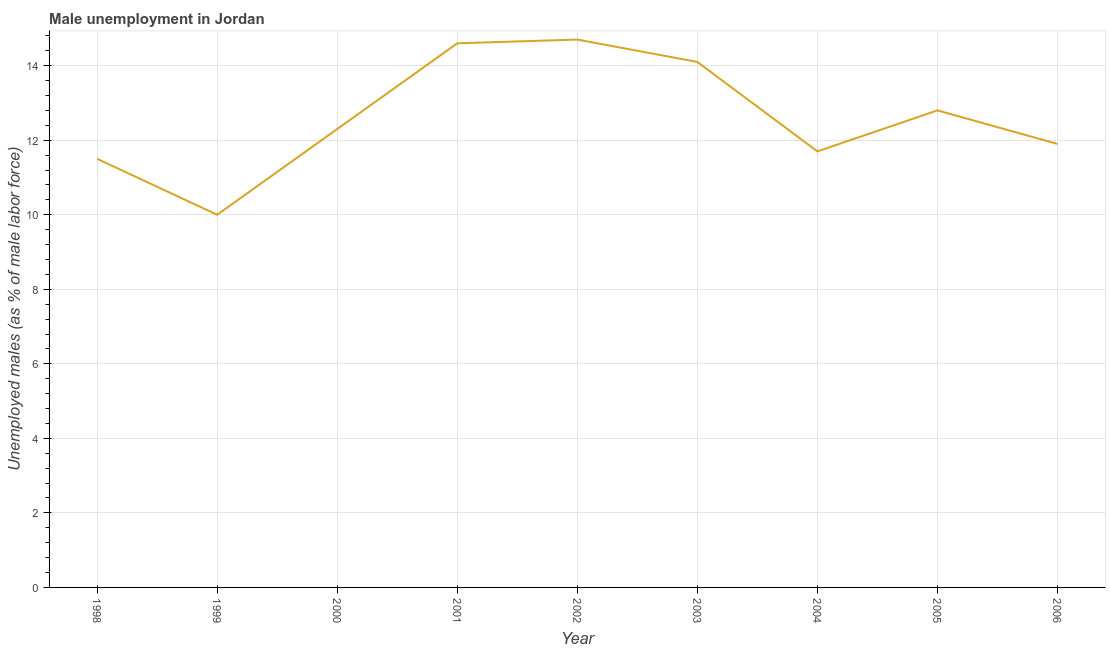What is the unemployed males population in 2004?
Keep it short and to the point. 11.7. Across all years, what is the maximum unemployed males population?
Your answer should be compact. 14.7. In which year was the unemployed males population maximum?
Ensure brevity in your answer.  2002. What is the sum of the unemployed males population?
Your answer should be compact. 113.6. What is the difference between the unemployed males population in 2000 and 2006?
Offer a very short reply. 0.4. What is the average unemployed males population per year?
Ensure brevity in your answer.  12.62. What is the median unemployed males population?
Your response must be concise. 12.3. In how many years, is the unemployed males population greater than 2 %?
Your answer should be compact. 9. What is the ratio of the unemployed males population in 2004 to that in 2006?
Your answer should be compact. 0.98. What is the difference between the highest and the second highest unemployed males population?
Offer a terse response. 0.1. What is the difference between the highest and the lowest unemployed males population?
Ensure brevity in your answer.  4.7. Does the unemployed males population monotonically increase over the years?
Your answer should be very brief. No. How many years are there in the graph?
Provide a short and direct response. 9. Are the values on the major ticks of Y-axis written in scientific E-notation?
Provide a short and direct response. No. Does the graph contain grids?
Keep it short and to the point. Yes. What is the title of the graph?
Provide a succinct answer. Male unemployment in Jordan. What is the label or title of the X-axis?
Your answer should be very brief. Year. What is the label or title of the Y-axis?
Offer a very short reply. Unemployed males (as % of male labor force). What is the Unemployed males (as % of male labor force) of 1999?
Offer a very short reply. 10. What is the Unemployed males (as % of male labor force) in 2000?
Make the answer very short. 12.3. What is the Unemployed males (as % of male labor force) of 2001?
Make the answer very short. 14.6. What is the Unemployed males (as % of male labor force) of 2002?
Ensure brevity in your answer.  14.7. What is the Unemployed males (as % of male labor force) of 2003?
Your answer should be compact. 14.1. What is the Unemployed males (as % of male labor force) in 2004?
Offer a very short reply. 11.7. What is the Unemployed males (as % of male labor force) in 2005?
Offer a very short reply. 12.8. What is the Unemployed males (as % of male labor force) of 2006?
Offer a terse response. 11.9. What is the difference between the Unemployed males (as % of male labor force) in 1998 and 1999?
Ensure brevity in your answer.  1.5. What is the difference between the Unemployed males (as % of male labor force) in 1998 and 2001?
Your response must be concise. -3.1. What is the difference between the Unemployed males (as % of male labor force) in 1998 and 2002?
Your answer should be compact. -3.2. What is the difference between the Unemployed males (as % of male labor force) in 1998 and 2003?
Ensure brevity in your answer.  -2.6. What is the difference between the Unemployed males (as % of male labor force) in 1998 and 2004?
Provide a short and direct response. -0.2. What is the difference between the Unemployed males (as % of male labor force) in 1998 and 2006?
Provide a short and direct response. -0.4. What is the difference between the Unemployed males (as % of male labor force) in 1999 and 2000?
Make the answer very short. -2.3. What is the difference between the Unemployed males (as % of male labor force) in 1999 and 2002?
Give a very brief answer. -4.7. What is the difference between the Unemployed males (as % of male labor force) in 1999 and 2004?
Offer a very short reply. -1.7. What is the difference between the Unemployed males (as % of male labor force) in 2000 and 2003?
Ensure brevity in your answer.  -1.8. What is the difference between the Unemployed males (as % of male labor force) in 2001 and 2005?
Your answer should be very brief. 1.8. What is the difference between the Unemployed males (as % of male labor force) in 2003 and 2006?
Offer a very short reply. 2.2. What is the difference between the Unemployed males (as % of male labor force) in 2004 and 2006?
Make the answer very short. -0.2. What is the difference between the Unemployed males (as % of male labor force) in 2005 and 2006?
Provide a succinct answer. 0.9. What is the ratio of the Unemployed males (as % of male labor force) in 1998 to that in 1999?
Make the answer very short. 1.15. What is the ratio of the Unemployed males (as % of male labor force) in 1998 to that in 2000?
Make the answer very short. 0.94. What is the ratio of the Unemployed males (as % of male labor force) in 1998 to that in 2001?
Offer a very short reply. 0.79. What is the ratio of the Unemployed males (as % of male labor force) in 1998 to that in 2002?
Your response must be concise. 0.78. What is the ratio of the Unemployed males (as % of male labor force) in 1998 to that in 2003?
Your answer should be compact. 0.82. What is the ratio of the Unemployed males (as % of male labor force) in 1998 to that in 2005?
Give a very brief answer. 0.9. What is the ratio of the Unemployed males (as % of male labor force) in 1999 to that in 2000?
Your answer should be compact. 0.81. What is the ratio of the Unemployed males (as % of male labor force) in 1999 to that in 2001?
Give a very brief answer. 0.69. What is the ratio of the Unemployed males (as % of male labor force) in 1999 to that in 2002?
Keep it short and to the point. 0.68. What is the ratio of the Unemployed males (as % of male labor force) in 1999 to that in 2003?
Your answer should be very brief. 0.71. What is the ratio of the Unemployed males (as % of male labor force) in 1999 to that in 2004?
Offer a terse response. 0.85. What is the ratio of the Unemployed males (as % of male labor force) in 1999 to that in 2005?
Your answer should be compact. 0.78. What is the ratio of the Unemployed males (as % of male labor force) in 1999 to that in 2006?
Ensure brevity in your answer.  0.84. What is the ratio of the Unemployed males (as % of male labor force) in 2000 to that in 2001?
Provide a succinct answer. 0.84. What is the ratio of the Unemployed males (as % of male labor force) in 2000 to that in 2002?
Your answer should be very brief. 0.84. What is the ratio of the Unemployed males (as % of male labor force) in 2000 to that in 2003?
Offer a terse response. 0.87. What is the ratio of the Unemployed males (as % of male labor force) in 2000 to that in 2004?
Provide a short and direct response. 1.05. What is the ratio of the Unemployed males (as % of male labor force) in 2000 to that in 2005?
Offer a terse response. 0.96. What is the ratio of the Unemployed males (as % of male labor force) in 2000 to that in 2006?
Offer a terse response. 1.03. What is the ratio of the Unemployed males (as % of male labor force) in 2001 to that in 2002?
Your response must be concise. 0.99. What is the ratio of the Unemployed males (as % of male labor force) in 2001 to that in 2003?
Your response must be concise. 1.03. What is the ratio of the Unemployed males (as % of male labor force) in 2001 to that in 2004?
Your answer should be very brief. 1.25. What is the ratio of the Unemployed males (as % of male labor force) in 2001 to that in 2005?
Provide a short and direct response. 1.14. What is the ratio of the Unemployed males (as % of male labor force) in 2001 to that in 2006?
Provide a short and direct response. 1.23. What is the ratio of the Unemployed males (as % of male labor force) in 2002 to that in 2003?
Your response must be concise. 1.04. What is the ratio of the Unemployed males (as % of male labor force) in 2002 to that in 2004?
Give a very brief answer. 1.26. What is the ratio of the Unemployed males (as % of male labor force) in 2002 to that in 2005?
Your answer should be compact. 1.15. What is the ratio of the Unemployed males (as % of male labor force) in 2002 to that in 2006?
Ensure brevity in your answer.  1.24. What is the ratio of the Unemployed males (as % of male labor force) in 2003 to that in 2004?
Your answer should be compact. 1.21. What is the ratio of the Unemployed males (as % of male labor force) in 2003 to that in 2005?
Make the answer very short. 1.1. What is the ratio of the Unemployed males (as % of male labor force) in 2003 to that in 2006?
Make the answer very short. 1.19. What is the ratio of the Unemployed males (as % of male labor force) in 2004 to that in 2005?
Your answer should be very brief. 0.91. What is the ratio of the Unemployed males (as % of male labor force) in 2004 to that in 2006?
Make the answer very short. 0.98. What is the ratio of the Unemployed males (as % of male labor force) in 2005 to that in 2006?
Give a very brief answer. 1.08. 